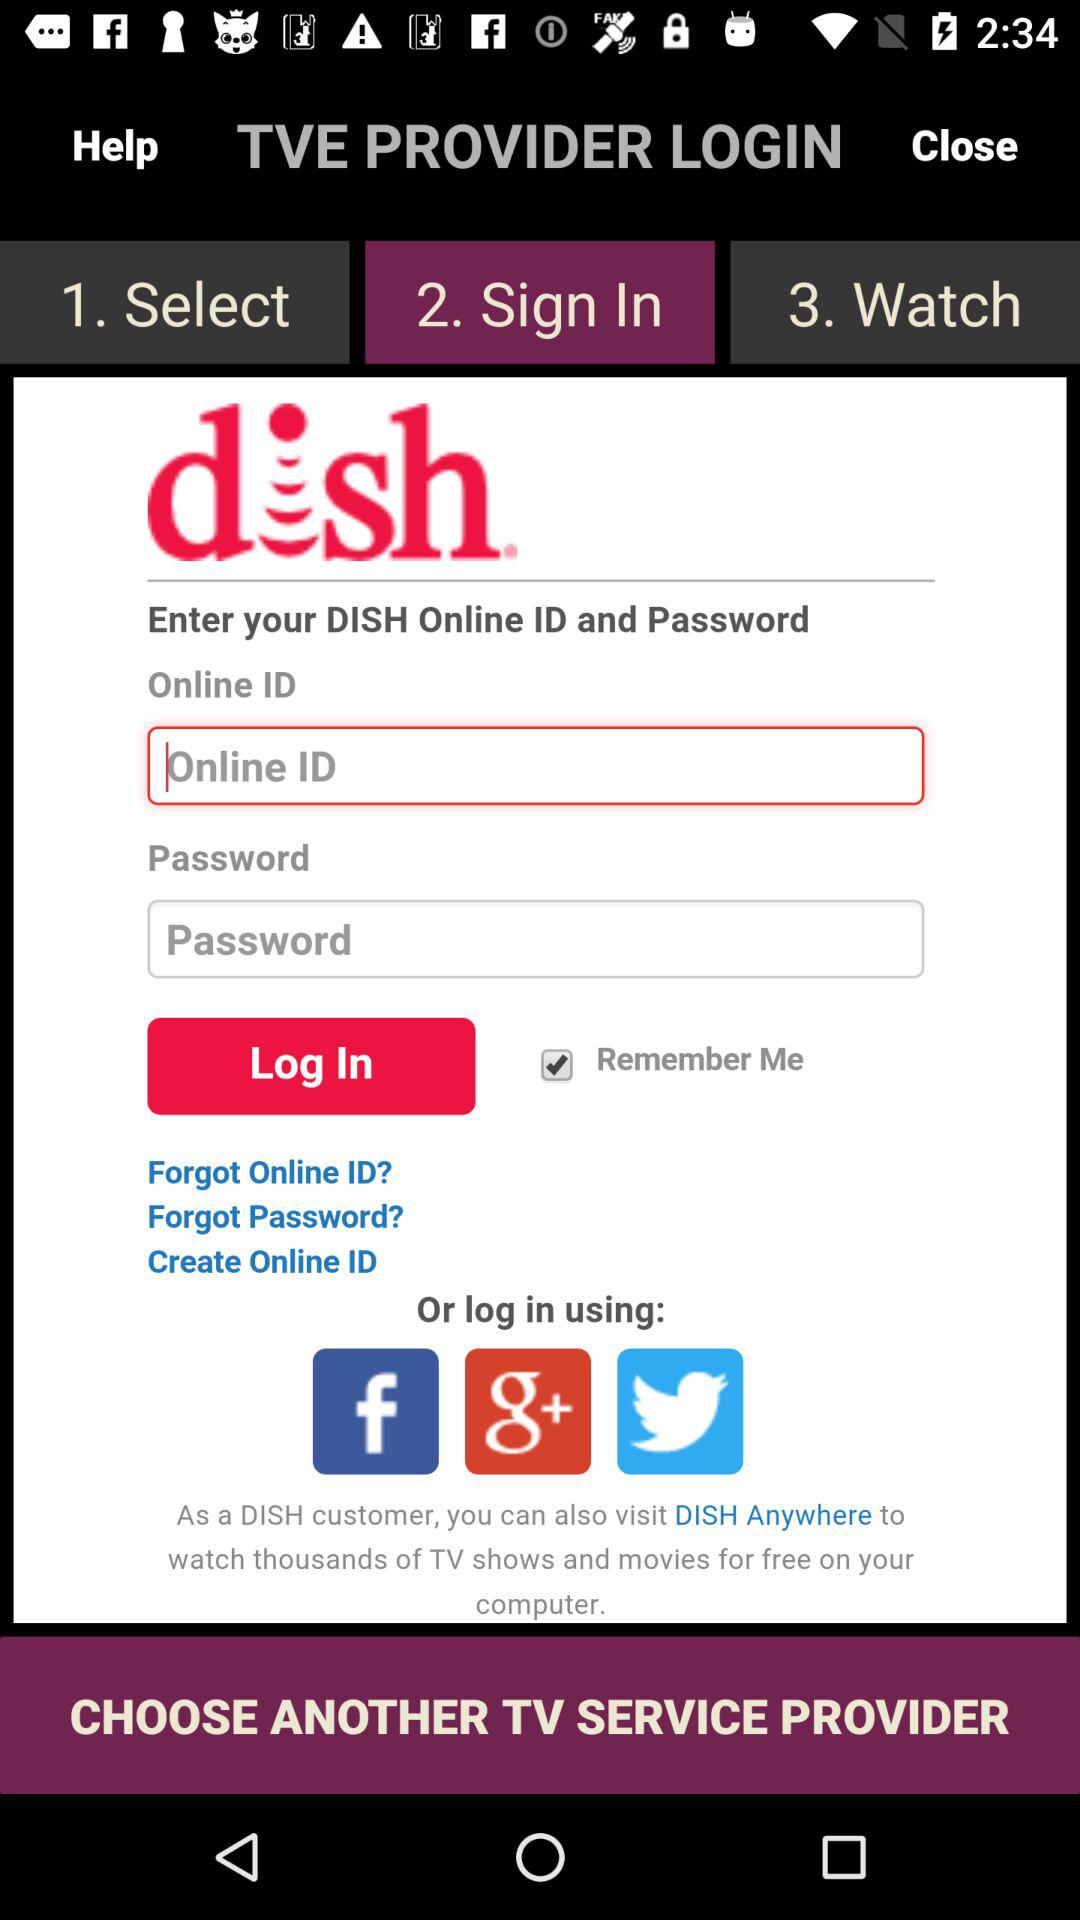What is the status of the "Remember Me" box? The status of the "Remember Me" box is "on". 